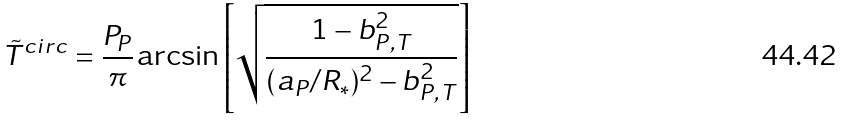Convert formula to latex. <formula><loc_0><loc_0><loc_500><loc_500>\tilde { T } ^ { c i r c } = \frac { P _ { P } } { \pi } \arcsin \left [ \sqrt { \frac { 1 - b _ { P , T } ^ { 2 } } { ( a _ { P } / R _ { * } ) ^ { 2 } - b _ { P , T } ^ { 2 } } } \right ]</formula> 